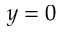<formula> <loc_0><loc_0><loc_500><loc_500>y = 0</formula> 